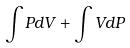Convert formula to latex. <formula><loc_0><loc_0><loc_500><loc_500>\int P d V + \int V d P</formula> 